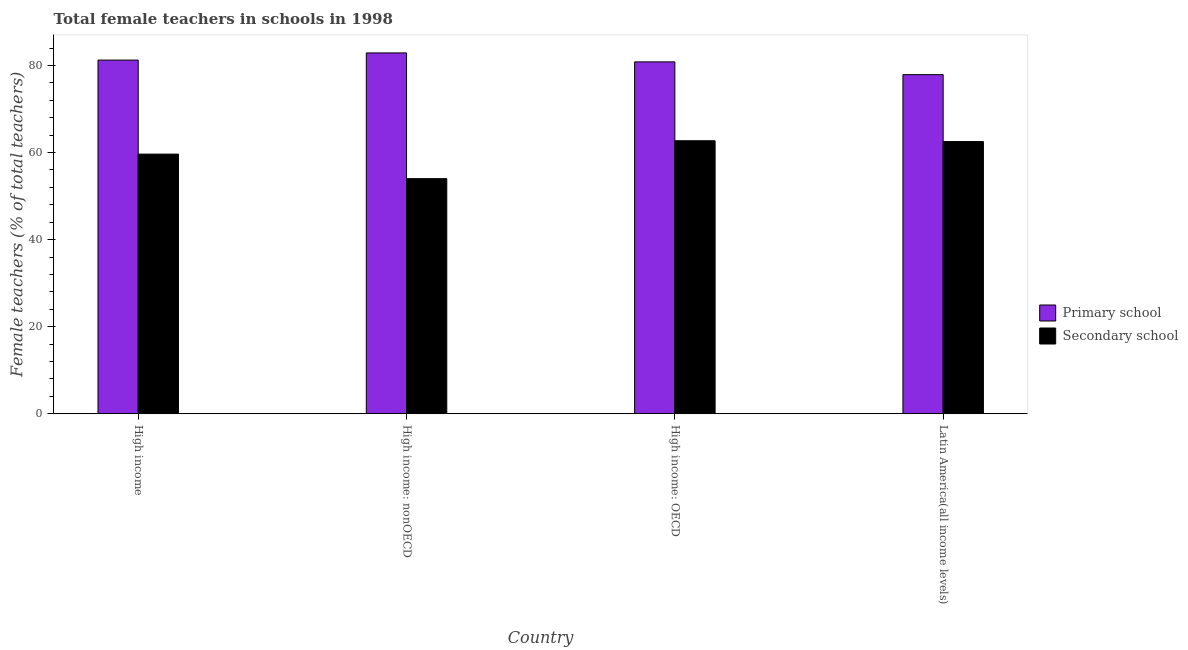How many groups of bars are there?
Your response must be concise. 4. Are the number of bars per tick equal to the number of legend labels?
Your response must be concise. Yes. What is the label of the 4th group of bars from the left?
Your answer should be compact. Latin America(all income levels). What is the percentage of female teachers in primary schools in Latin America(all income levels)?
Provide a succinct answer. 77.89. Across all countries, what is the maximum percentage of female teachers in secondary schools?
Provide a succinct answer. 62.71. Across all countries, what is the minimum percentage of female teachers in secondary schools?
Provide a short and direct response. 54. In which country was the percentage of female teachers in secondary schools maximum?
Your response must be concise. High income: OECD. In which country was the percentage of female teachers in secondary schools minimum?
Give a very brief answer. High income: nonOECD. What is the total percentage of female teachers in primary schools in the graph?
Make the answer very short. 322.84. What is the difference between the percentage of female teachers in primary schools in High income and that in Latin America(all income levels)?
Ensure brevity in your answer.  3.35. What is the difference between the percentage of female teachers in primary schools in High income: OECD and the percentage of female teachers in secondary schools in Latin America(all income levels)?
Give a very brief answer. 18.3. What is the average percentage of female teachers in secondary schools per country?
Your answer should be very brief. 59.72. What is the difference between the percentage of female teachers in secondary schools and percentage of female teachers in primary schools in High income: OECD?
Offer a terse response. -18.12. What is the ratio of the percentage of female teachers in primary schools in High income to that in High income: OECD?
Your response must be concise. 1.01. Is the percentage of female teachers in primary schools in High income: OECD less than that in Latin America(all income levels)?
Offer a terse response. No. What is the difference between the highest and the second highest percentage of female teachers in secondary schools?
Your answer should be very brief. 0.19. What is the difference between the highest and the lowest percentage of female teachers in secondary schools?
Offer a terse response. 8.71. Is the sum of the percentage of female teachers in secondary schools in High income and Latin America(all income levels) greater than the maximum percentage of female teachers in primary schools across all countries?
Provide a short and direct response. Yes. What does the 2nd bar from the left in Latin America(all income levels) represents?
Provide a short and direct response. Secondary school. What does the 1st bar from the right in Latin America(all income levels) represents?
Give a very brief answer. Secondary school. Are all the bars in the graph horizontal?
Offer a terse response. No. What is the difference between two consecutive major ticks on the Y-axis?
Provide a short and direct response. 20. Are the values on the major ticks of Y-axis written in scientific E-notation?
Your response must be concise. No. Does the graph contain any zero values?
Your response must be concise. No. Does the graph contain grids?
Keep it short and to the point. No. Where does the legend appear in the graph?
Ensure brevity in your answer.  Center right. What is the title of the graph?
Offer a very short reply. Total female teachers in schools in 1998. Does "International Visitors" appear as one of the legend labels in the graph?
Your answer should be compact. No. What is the label or title of the X-axis?
Offer a very short reply. Country. What is the label or title of the Y-axis?
Your answer should be compact. Female teachers (% of total teachers). What is the Female teachers (% of total teachers) of Primary school in High income?
Keep it short and to the point. 81.24. What is the Female teachers (% of total teachers) of Secondary school in High income?
Ensure brevity in your answer.  59.64. What is the Female teachers (% of total teachers) of Primary school in High income: nonOECD?
Your answer should be very brief. 82.88. What is the Female teachers (% of total teachers) in Secondary school in High income: nonOECD?
Provide a short and direct response. 54. What is the Female teachers (% of total teachers) of Primary school in High income: OECD?
Provide a succinct answer. 80.83. What is the Female teachers (% of total teachers) of Secondary school in High income: OECD?
Offer a very short reply. 62.71. What is the Female teachers (% of total teachers) of Primary school in Latin America(all income levels)?
Your answer should be very brief. 77.89. What is the Female teachers (% of total teachers) in Secondary school in Latin America(all income levels)?
Keep it short and to the point. 62.52. Across all countries, what is the maximum Female teachers (% of total teachers) of Primary school?
Your answer should be very brief. 82.88. Across all countries, what is the maximum Female teachers (% of total teachers) in Secondary school?
Give a very brief answer. 62.71. Across all countries, what is the minimum Female teachers (% of total teachers) of Primary school?
Offer a terse response. 77.89. Across all countries, what is the minimum Female teachers (% of total teachers) of Secondary school?
Keep it short and to the point. 54. What is the total Female teachers (% of total teachers) in Primary school in the graph?
Provide a succinct answer. 322.84. What is the total Female teachers (% of total teachers) in Secondary school in the graph?
Provide a succinct answer. 238.88. What is the difference between the Female teachers (% of total teachers) of Primary school in High income and that in High income: nonOECD?
Offer a very short reply. -1.65. What is the difference between the Female teachers (% of total teachers) in Secondary school in High income and that in High income: nonOECD?
Your answer should be very brief. 5.64. What is the difference between the Female teachers (% of total teachers) in Primary school in High income and that in High income: OECD?
Your response must be concise. 0.41. What is the difference between the Female teachers (% of total teachers) in Secondary school in High income and that in High income: OECD?
Your answer should be compact. -3.07. What is the difference between the Female teachers (% of total teachers) of Primary school in High income and that in Latin America(all income levels)?
Your response must be concise. 3.35. What is the difference between the Female teachers (% of total teachers) in Secondary school in High income and that in Latin America(all income levels)?
Give a very brief answer. -2.88. What is the difference between the Female teachers (% of total teachers) of Primary school in High income: nonOECD and that in High income: OECD?
Make the answer very short. 2.06. What is the difference between the Female teachers (% of total teachers) in Secondary school in High income: nonOECD and that in High income: OECD?
Offer a very short reply. -8.71. What is the difference between the Female teachers (% of total teachers) in Primary school in High income: nonOECD and that in Latin America(all income levels)?
Make the answer very short. 4.99. What is the difference between the Female teachers (% of total teachers) of Secondary school in High income: nonOECD and that in Latin America(all income levels)?
Keep it short and to the point. -8.52. What is the difference between the Female teachers (% of total teachers) in Primary school in High income: OECD and that in Latin America(all income levels)?
Offer a very short reply. 2.93. What is the difference between the Female teachers (% of total teachers) in Secondary school in High income: OECD and that in Latin America(all income levels)?
Your answer should be compact. 0.19. What is the difference between the Female teachers (% of total teachers) of Primary school in High income and the Female teachers (% of total teachers) of Secondary school in High income: nonOECD?
Keep it short and to the point. 27.23. What is the difference between the Female teachers (% of total teachers) of Primary school in High income and the Female teachers (% of total teachers) of Secondary school in High income: OECD?
Make the answer very short. 18.53. What is the difference between the Female teachers (% of total teachers) in Primary school in High income and the Female teachers (% of total teachers) in Secondary school in Latin America(all income levels)?
Offer a very short reply. 18.72. What is the difference between the Female teachers (% of total teachers) in Primary school in High income: nonOECD and the Female teachers (% of total teachers) in Secondary school in High income: OECD?
Ensure brevity in your answer.  20.18. What is the difference between the Female teachers (% of total teachers) in Primary school in High income: nonOECD and the Female teachers (% of total teachers) in Secondary school in Latin America(all income levels)?
Keep it short and to the point. 20.36. What is the difference between the Female teachers (% of total teachers) in Primary school in High income: OECD and the Female teachers (% of total teachers) in Secondary school in Latin America(all income levels)?
Your answer should be very brief. 18.3. What is the average Female teachers (% of total teachers) in Primary school per country?
Provide a short and direct response. 80.71. What is the average Female teachers (% of total teachers) of Secondary school per country?
Your answer should be very brief. 59.72. What is the difference between the Female teachers (% of total teachers) in Primary school and Female teachers (% of total teachers) in Secondary school in High income?
Ensure brevity in your answer.  21.6. What is the difference between the Female teachers (% of total teachers) of Primary school and Female teachers (% of total teachers) of Secondary school in High income: nonOECD?
Ensure brevity in your answer.  28.88. What is the difference between the Female teachers (% of total teachers) of Primary school and Female teachers (% of total teachers) of Secondary school in High income: OECD?
Offer a very short reply. 18.12. What is the difference between the Female teachers (% of total teachers) in Primary school and Female teachers (% of total teachers) in Secondary school in Latin America(all income levels)?
Your response must be concise. 15.37. What is the ratio of the Female teachers (% of total teachers) in Primary school in High income to that in High income: nonOECD?
Make the answer very short. 0.98. What is the ratio of the Female teachers (% of total teachers) of Secondary school in High income to that in High income: nonOECD?
Provide a succinct answer. 1.1. What is the ratio of the Female teachers (% of total teachers) of Secondary school in High income to that in High income: OECD?
Make the answer very short. 0.95. What is the ratio of the Female teachers (% of total teachers) of Primary school in High income to that in Latin America(all income levels)?
Offer a terse response. 1.04. What is the ratio of the Female teachers (% of total teachers) in Secondary school in High income to that in Latin America(all income levels)?
Provide a succinct answer. 0.95. What is the ratio of the Female teachers (% of total teachers) in Primary school in High income: nonOECD to that in High income: OECD?
Your response must be concise. 1.03. What is the ratio of the Female teachers (% of total teachers) in Secondary school in High income: nonOECD to that in High income: OECD?
Keep it short and to the point. 0.86. What is the ratio of the Female teachers (% of total teachers) of Primary school in High income: nonOECD to that in Latin America(all income levels)?
Provide a succinct answer. 1.06. What is the ratio of the Female teachers (% of total teachers) of Secondary school in High income: nonOECD to that in Latin America(all income levels)?
Offer a very short reply. 0.86. What is the ratio of the Female teachers (% of total teachers) in Primary school in High income: OECD to that in Latin America(all income levels)?
Give a very brief answer. 1.04. What is the ratio of the Female teachers (% of total teachers) in Secondary school in High income: OECD to that in Latin America(all income levels)?
Keep it short and to the point. 1. What is the difference between the highest and the second highest Female teachers (% of total teachers) in Primary school?
Provide a short and direct response. 1.65. What is the difference between the highest and the second highest Female teachers (% of total teachers) of Secondary school?
Offer a very short reply. 0.19. What is the difference between the highest and the lowest Female teachers (% of total teachers) in Primary school?
Your response must be concise. 4.99. What is the difference between the highest and the lowest Female teachers (% of total teachers) in Secondary school?
Provide a short and direct response. 8.71. 